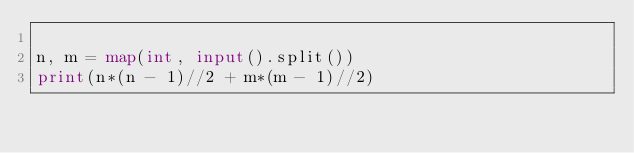<code> <loc_0><loc_0><loc_500><loc_500><_Python_>
n, m = map(int, input().split())
print(n*(n - 1)//2 + m*(m - 1)//2)</code> 